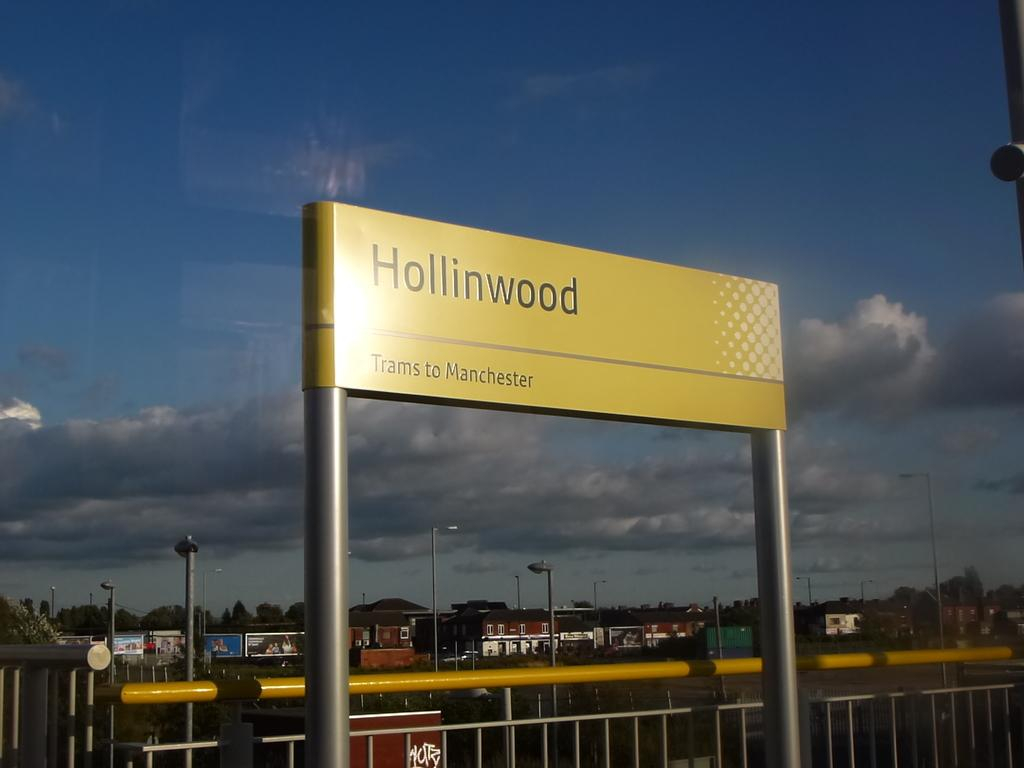<image>
Write a terse but informative summary of the picture. A yellow sign that says Hollinwood and Trams to Manchester. 